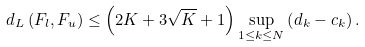<formula> <loc_0><loc_0><loc_500><loc_500>d _ { L } \left ( F _ { l } , F _ { u } \right ) \leq \left ( 2 K + 3 \sqrt { K } + 1 \right ) \sup _ { 1 \leq k \leq N } \left ( d _ { k } - c _ { k } \right ) .</formula> 